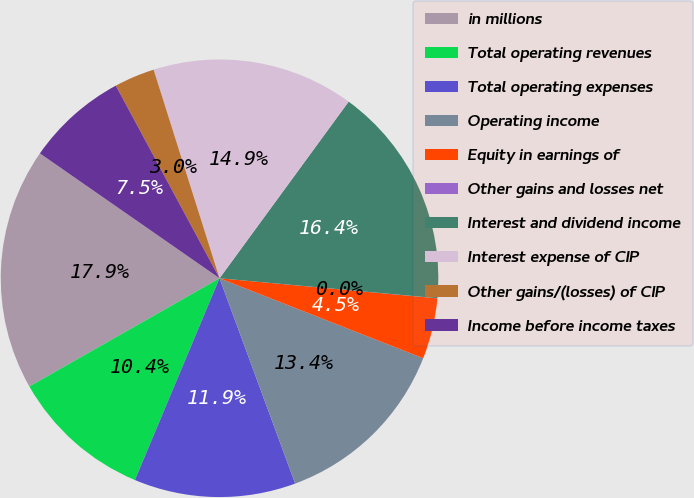Convert chart to OTSL. <chart><loc_0><loc_0><loc_500><loc_500><pie_chart><fcel>in millions<fcel>Total operating revenues<fcel>Total operating expenses<fcel>Operating income<fcel>Equity in earnings of<fcel>Other gains and losses net<fcel>Interest and dividend income<fcel>Interest expense of CIP<fcel>Other gains/(losses) of CIP<fcel>Income before income taxes<nl><fcel>17.9%<fcel>10.45%<fcel>11.94%<fcel>13.43%<fcel>4.49%<fcel>0.01%<fcel>16.41%<fcel>14.92%<fcel>2.99%<fcel>7.47%<nl></chart> 